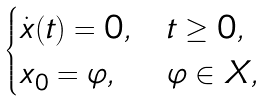<formula> <loc_0><loc_0><loc_500><loc_500>\begin{cases} \dot { x } ( t ) = 0 , & t \geq 0 , \\ x _ { 0 } = \varphi , & \varphi \in X , \end{cases}</formula> 